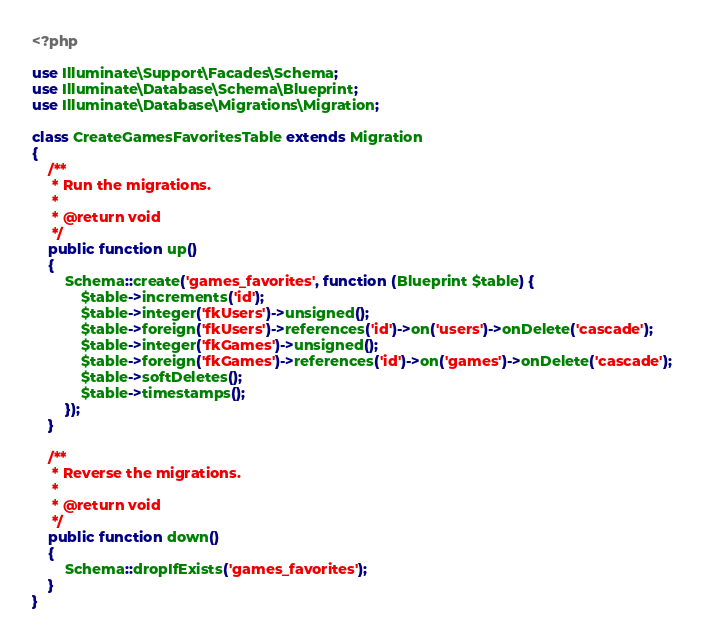<code> <loc_0><loc_0><loc_500><loc_500><_PHP_><?php

use Illuminate\Support\Facades\Schema;
use Illuminate\Database\Schema\Blueprint;
use Illuminate\Database\Migrations\Migration;

class CreateGamesFavoritesTable extends Migration
{
    /**
     * Run the migrations.
     *
     * @return void
     */
    public function up()
    {
        Schema::create('games_favorites', function (Blueprint $table) {
            $table->increments('id');
            $table->integer('fkUsers')->unsigned();
            $table->foreign('fkUsers')->references('id')->on('users')->onDelete('cascade');
            $table->integer('fkGames')->unsigned();
            $table->foreign('fkGames')->references('id')->on('games')->onDelete('cascade');
            $table->softDeletes();
            $table->timestamps();
        });
    }

    /**
     * Reverse the migrations.
     *
     * @return void
     */
    public function down()
    {
        Schema::dropIfExists('games_favorites');
    }
}
</code> 